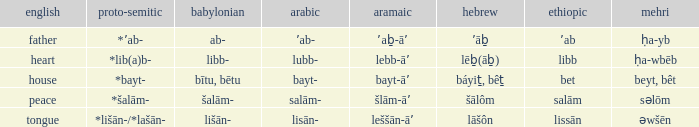Help me parse the entirety of this table. {'header': ['english', 'proto-semitic', 'babylonian', 'arabic', 'aramaic', 'hebrew', 'ethiopic', 'mehri'], 'rows': [['father', '*ʼab-', 'ab-', 'ʼab-', 'ʼaḇ-āʼ', 'ʼāḇ', 'ʼab', 'ḥa-yb'], ['heart', '*lib(a)b-', 'libb-', 'lubb-', 'lebb-āʼ', 'lēḇ(āḇ)', 'libb', 'ḥa-wbēb'], ['house', '*bayt-', 'bītu, bētu', 'bayt-', 'bayt-āʼ', 'báyiṯ, bêṯ', 'bet', 'beyt, bêt'], ['peace', '*šalām-', 'šalām-', 'salām-', 'šlām-āʼ', 'šālôm', 'salām', 'səlōm'], ['tongue', '*lišān-/*lašān-', 'lišān-', 'lisān-', 'leššān-āʼ', 'lāšôn', 'lissān', 'əwšēn']]} If the geez is libb, what is the akkadian? Libb-. 